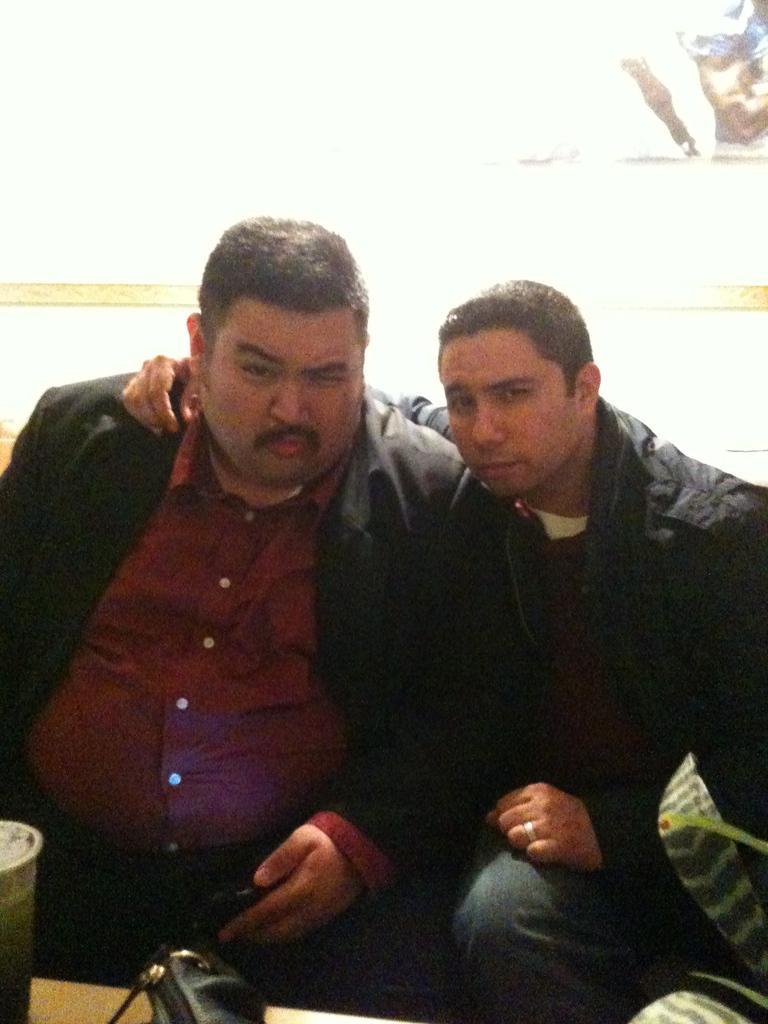Please provide a concise description of this image. In this image I can see two persons wearing black jackets are sitting in front of a desk and on the desk I can see a bag and few other objects. I can see the white colored background. 